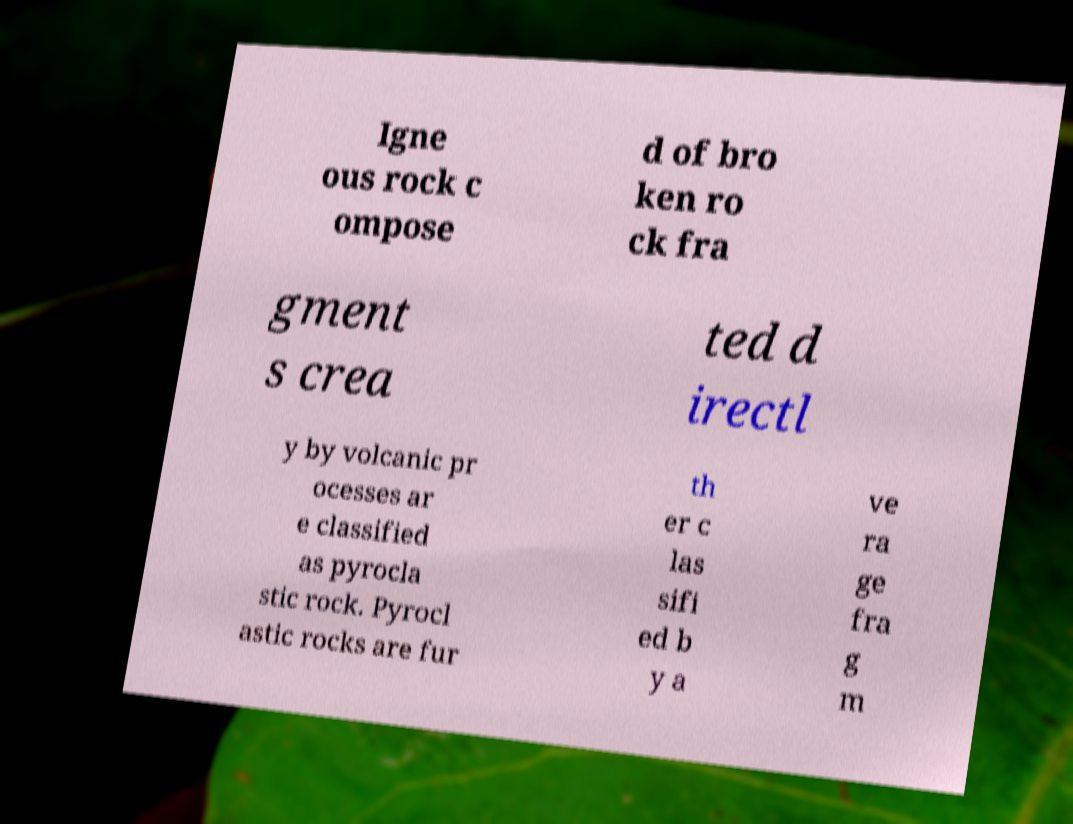What messages or text are displayed in this image? I need them in a readable, typed format. Igne ous rock c ompose d of bro ken ro ck fra gment s crea ted d irectl y by volcanic pr ocesses ar e classified as pyrocla stic rock. Pyrocl astic rocks are fur th er c las sifi ed b y a ve ra ge fra g m 